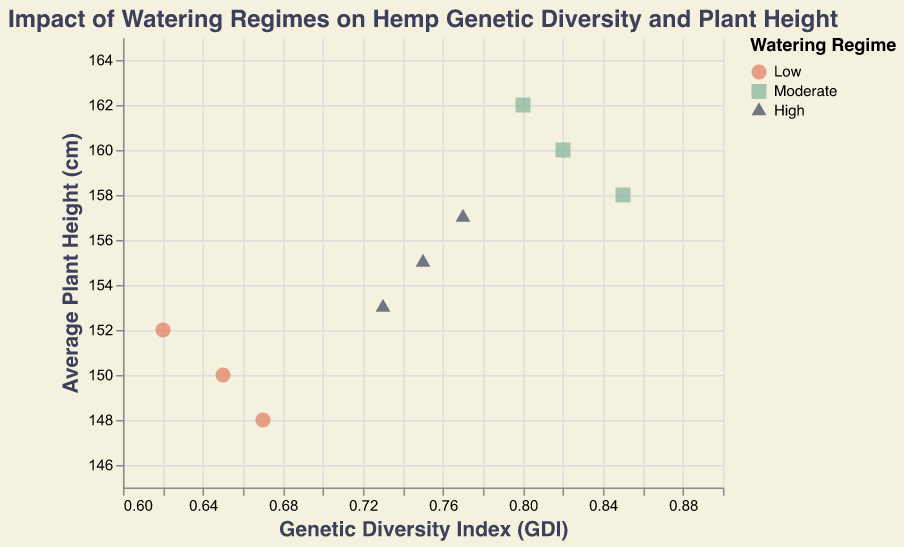What are the three different watering regimes represented in the scatter plot? The scatter plot uses color and shape to represent the three different watering regimes. From the legend, we see the three categories: Low (circle), Moderate (square), and High (triangle)
Answer: Low, Moderate, High What is the title of the scatter plot? The title is shown at the top of the figure, which describes the overall subject of the visualized data.
Answer: Impact of Watering Regimes on Hemp Genetic Diversity and Plant Height How many data points are there for each watering regime? By observing the scatter plot and counting the different shapes and colors representing each regime, we see three circles (Low), three squares (Moderate), and three triangles (High)
Answer: 3 for each Which watering regime has the highest genetic diversity index? By examining the x-axis values for each watering regime and comparing them, we see that Moderate has the highest values, with a maximum GDI of 0.85.
Answer: Moderate What is the genetic diversity index and average plant height for the highest data point? Looking at the point with the greatest x-axis value (0.85), we also check the y-axis and refer to the tooltip information shown for that point.
Answer: 0.85 GDI and 158 cm height Which watering regime appears to produce the tallest average plants? By comparing the average plant heights along the y-axis for different colors (representing the regimes), we see that Moderate consistently has higher values (around 160-162 cm).
Answer: Moderate What's the range of genetic diversity indices in the Low watering regime? By looking at the points for the Low regime and noting the x-axis values, we see they range from 0.62 to 0.67.
Answer: 0.62 to 0.67 Does the High watering regime show higher or lower genetic diversity compared to the Moderate regime? Comparing the x-axis positions of the High (triangle) points to the Moderate (square) points shows that the High regime has generally lower GDI values.
Answer: Lower What is the average genetic diversity index for Moderate watering regime? The GDI values for Moderate are 0.82, 0.80, and 0.85. Summing these values and dividing by the number of points, (0.82 + 0.80 + 0.85) / 3 = 2.47 / 3 = 0.823.
Answer: 0.823 Which watering regime has the smallest spread in average plant height? By examining the vertical spread of points for each regime on the y-axis, we see that the Low regime's points vary from 148 cm to 152 cm, showing the smallest spread of 4 cm.
Answer: Low 